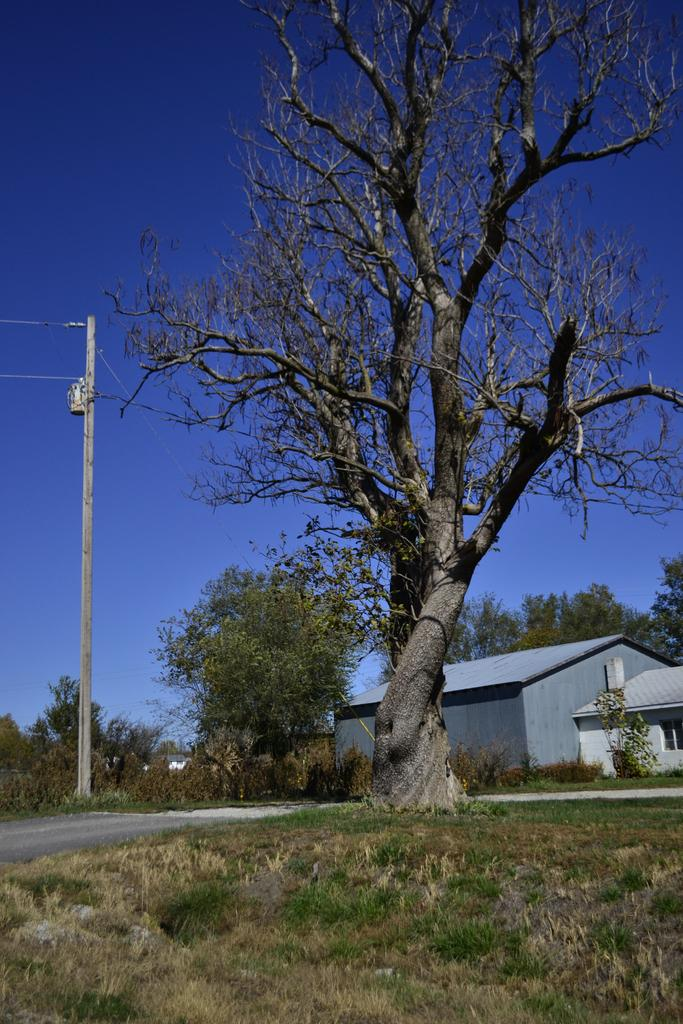What type of plant is visible on the ground in the image? There is a tree on the ground in the image. What type of vegetation is present in the image? There is grass in the image. What can be seen in the background of the image? There is a white-colored pole, trees, buildings, wires, and the sky visible in the background of the image. How many cats are playing with the ant in the image? There are no cats or ants present in the image. 